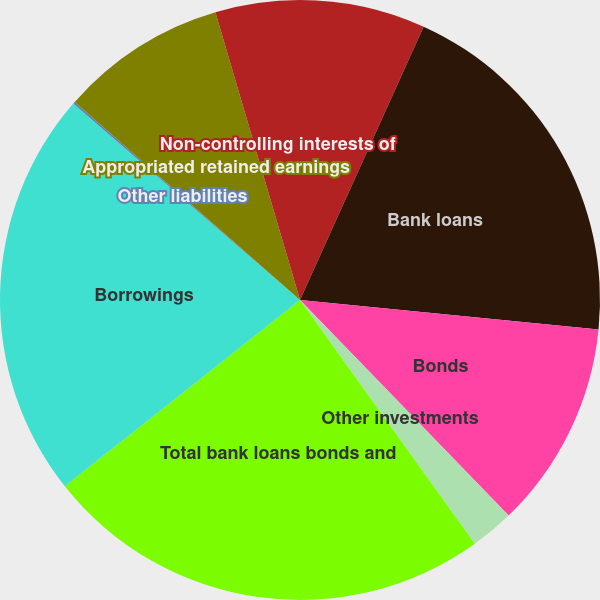<chart> <loc_0><loc_0><loc_500><loc_500><pie_chart><fcel>Cash and cash equivalents<fcel>Bank loans<fcel>Bonds<fcel>Other investments<fcel>Total bank loans bonds and<fcel>Borrowings<fcel>Other liabilities<fcel>Appropriated retained earnings<fcel>Non-controlling interests of<nl><fcel>6.76%<fcel>19.81%<fcel>11.19%<fcel>2.34%<fcel>24.24%<fcel>22.02%<fcel>0.12%<fcel>8.97%<fcel>4.55%<nl></chart> 